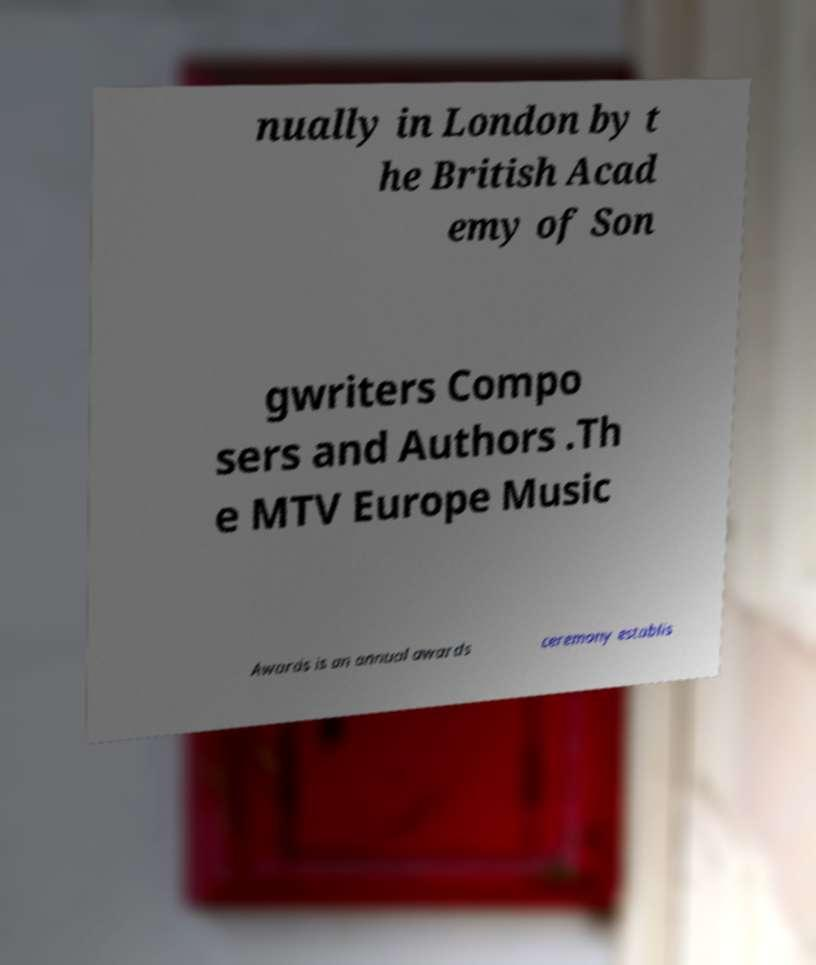Could you assist in decoding the text presented in this image and type it out clearly? nually in London by t he British Acad emy of Son gwriters Compo sers and Authors .Th e MTV Europe Music Awards is an annual awards ceremony establis 